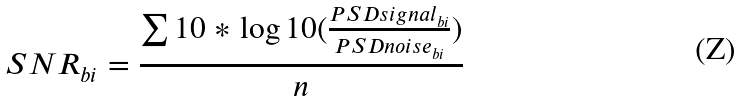<formula> <loc_0><loc_0><loc_500><loc_500>S N R _ { b i } = \frac { \sum { 1 0 * \log 1 0 ( \frac { P S D s i g n a l _ { b i } } { P S D n o i s e _ { b i } } ) } } { n }</formula> 